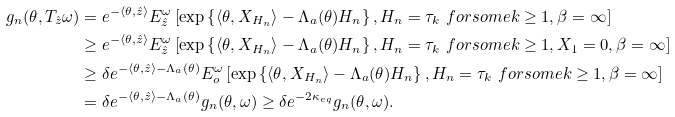<formula> <loc_0><loc_0><loc_500><loc_500>g _ { n } ( \theta , T _ { \hat { z } } \omega ) & = e ^ { - \langle \theta , \hat { z } \rangle } E _ { \hat { z } } ^ { \omega } \left [ \exp \left \{ \langle \theta , X _ { H _ { n } } \rangle - \Lambda _ { a } ( \theta ) H _ { n } \right \} , H _ { n } = \tau _ { k } \ f o r s o m e k \geq 1 , \beta = \infty \right ] \\ & \geq e ^ { - \langle \theta , \hat { z } \rangle } E _ { \hat { z } } ^ { \omega } \left [ \exp \left \{ \langle \theta , X _ { H _ { n } } \rangle - \Lambda _ { a } ( \theta ) H _ { n } \right \} , H _ { n } = \tau _ { k } \ f o r s o m e k \geq 1 , X _ { 1 } = 0 , \beta = \infty \right ] \\ & \geq \delta e ^ { - \langle \theta , \hat { z } \rangle - \Lambda _ { a } ( \theta ) } E _ { o } ^ { \omega } \left [ \exp \left \{ \langle \theta , X _ { H _ { n } } \rangle - \Lambda _ { a } ( \theta ) H _ { n } \right \} , H _ { n } = \tau _ { k } \ f o r s o m e k \geq 1 , \beta = \infty \right ] \\ & = \delta e ^ { - \langle \theta , \hat { z } \rangle - \Lambda _ { a } ( \theta ) } g _ { n } ( \theta , \omega ) \geq \delta e ^ { - 2 \kappa _ { e q } } g _ { n } ( \theta , \omega ) .</formula> 